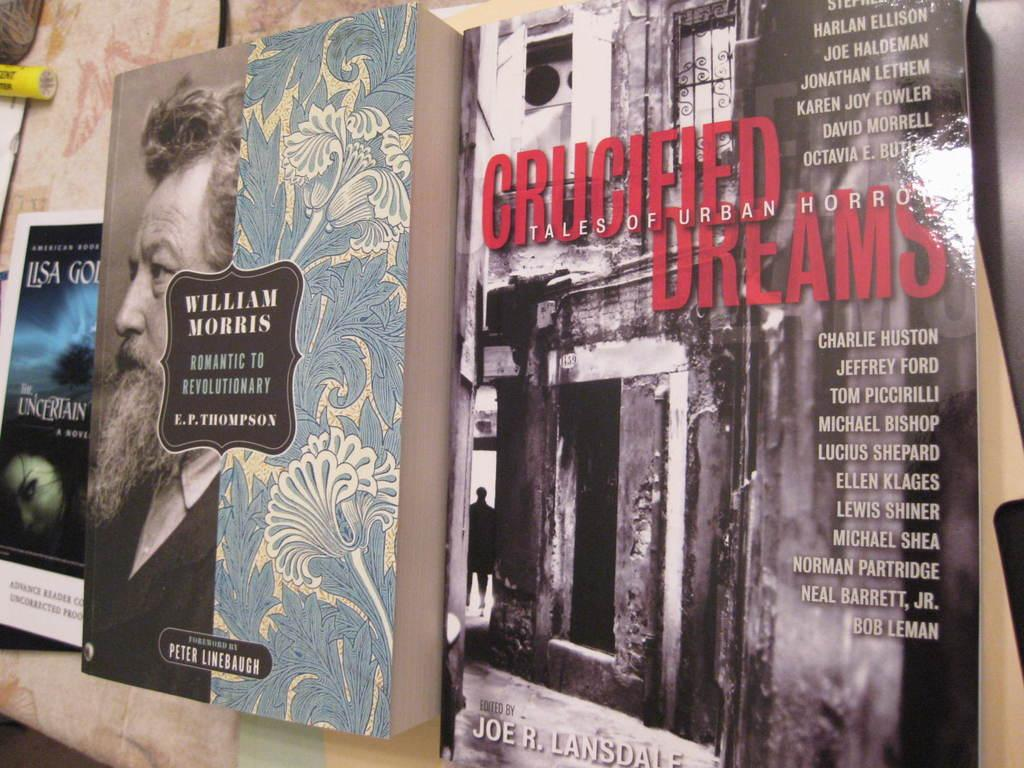<image>
Render a clear and concise summary of the photo. Books are standing on a ledge including one by William Morris. 